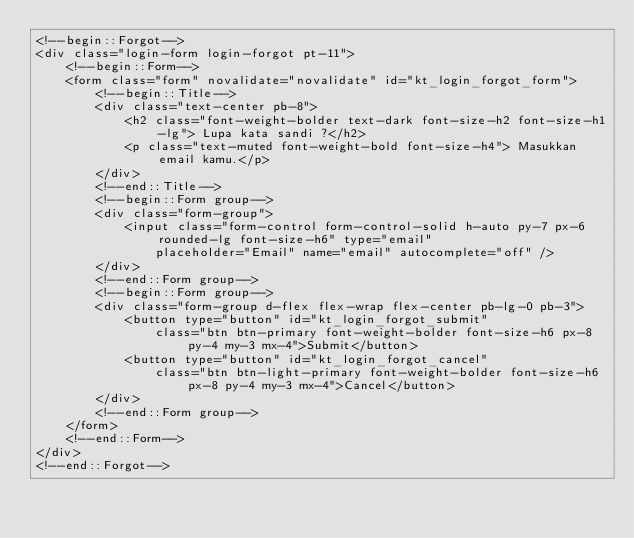Convert code to text. <code><loc_0><loc_0><loc_500><loc_500><_PHP_><!--begin::Forgot-->
<div class="login-form login-forgot pt-11">
    <!--begin::Form-->
    <form class="form" novalidate="novalidate" id="kt_login_forgot_form">
        <!--begin::Title-->
        <div class="text-center pb-8">
            <h2 class="font-weight-bolder text-dark font-size-h2 font-size-h1-lg"> Lupa kata sandi ?</h2>
            <p class="text-muted font-weight-bold font-size-h4"> Masukkan email kamu.</p>
        </div>
        <!--end::Title-->
        <!--begin::Form group-->
        <div class="form-group">
            <input class="form-control form-control-solid h-auto py-7 px-6 rounded-lg font-size-h6" type="email"
                placeholder="Email" name="email" autocomplete="off" />
        </div>
        <!--end::Form group-->
        <!--begin::Form group-->
        <div class="form-group d-flex flex-wrap flex-center pb-lg-0 pb-3">
            <button type="button" id="kt_login_forgot_submit"
                class="btn btn-primary font-weight-bolder font-size-h6 px-8 py-4 my-3 mx-4">Submit</button>
            <button type="button" id="kt_login_forgot_cancel"
                class="btn btn-light-primary font-weight-bolder font-size-h6 px-8 py-4 my-3 mx-4">Cancel</button>
        </div>
        <!--end::Form group-->
    </form>
    <!--end::Form-->
</div>
<!--end::Forgot--></code> 